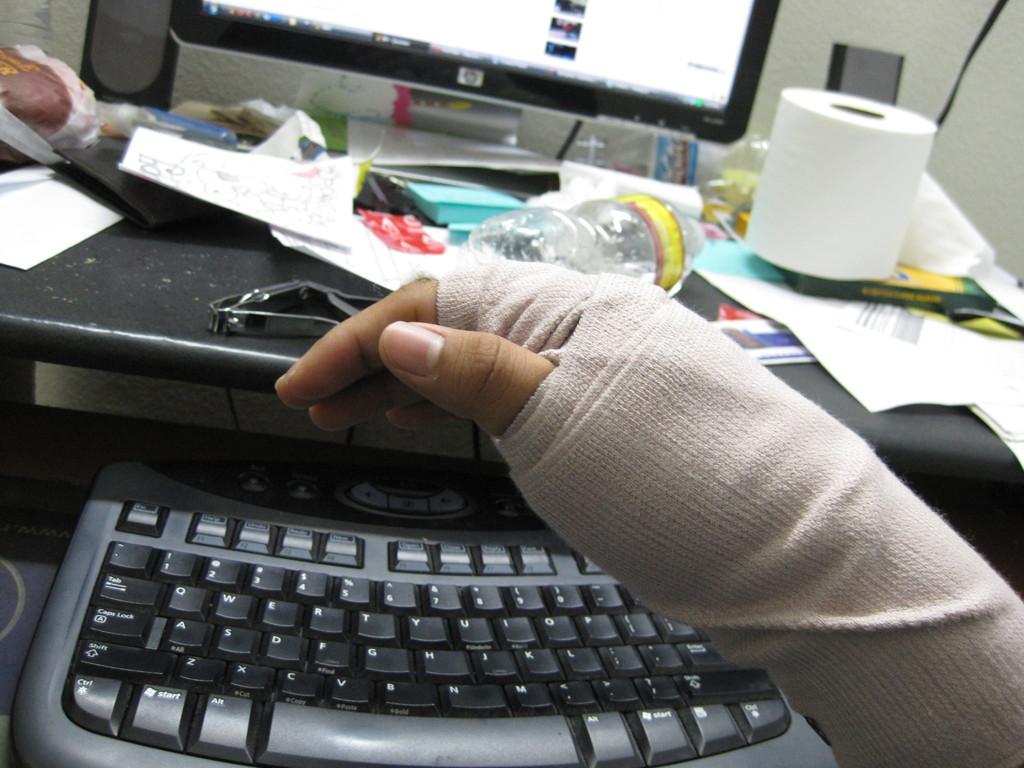What key is on the very bottom left?
Provide a succinct answer. Ctrl. What key is to the right of the spacebar?
Your answer should be compact. Alt. 